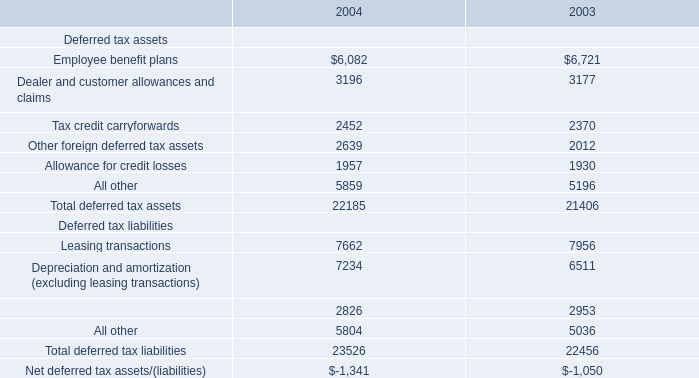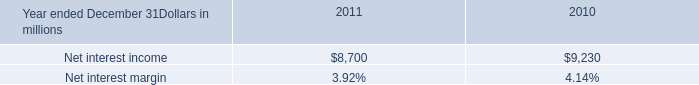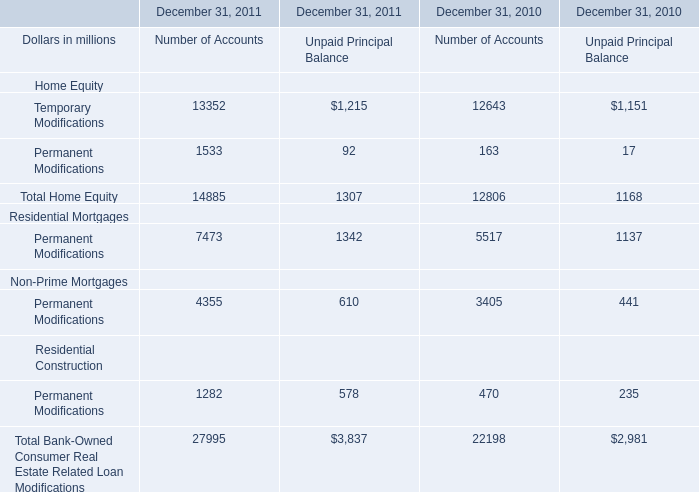what's the total amount of Temporary Modifications of December 31, 2011 Unpaid Principal Balance, Tax credit carryforwards of 2003, and Allowance for credit losses of 2003 ? 
Computations: ((1215.0 + 2370.0) + 1930.0)
Answer: 5515.0. What is the ratio of all Number of Accounts that are in the range of 1000 and 5000 in 2011? 
Computations: (((1533 + 4355) + 1282) / 27995)
Answer: 0.25612. Is the total amount of all elements in 2011 greater than that in 2010 for Number of Accounts? 
Answer: yes. What's the total value of all Number of Accounts that are in the range of 1000 and 5000 in 2011? 
Computations: ((1533 + 4355) + 1282)
Answer: 7170.0. 